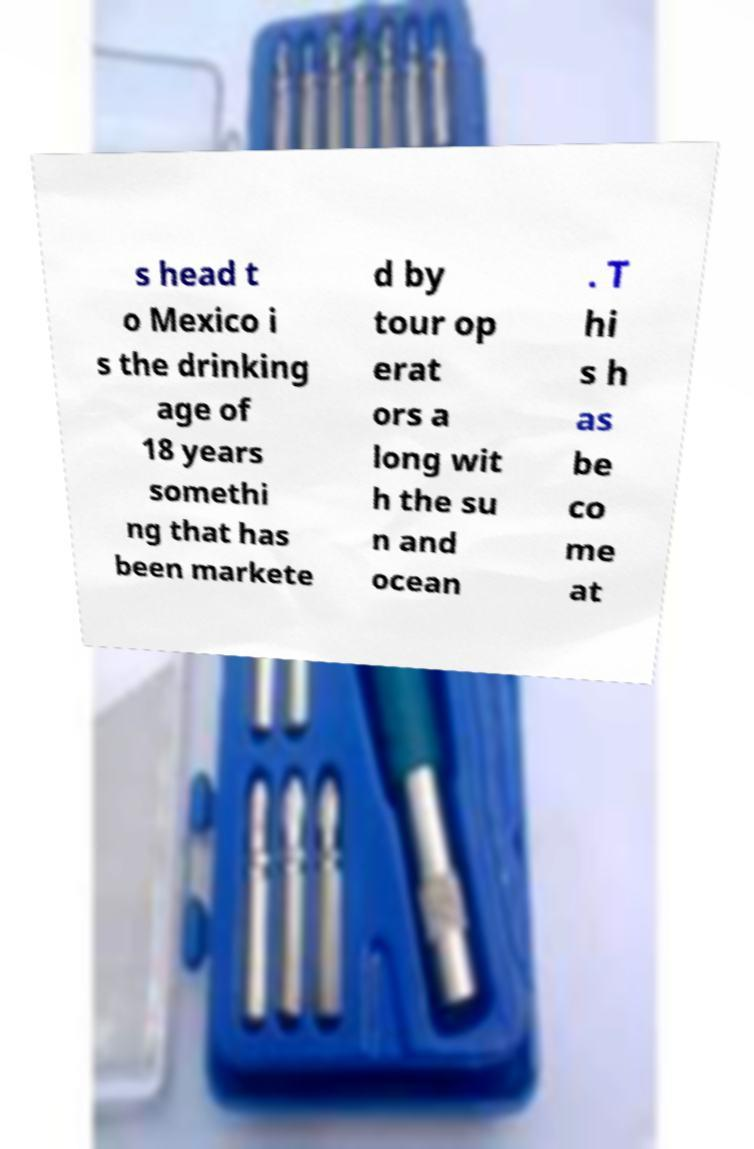Please identify and transcribe the text found in this image. s head t o Mexico i s the drinking age of 18 years somethi ng that has been markete d by tour op erat ors a long wit h the su n and ocean . T hi s h as be co me at 